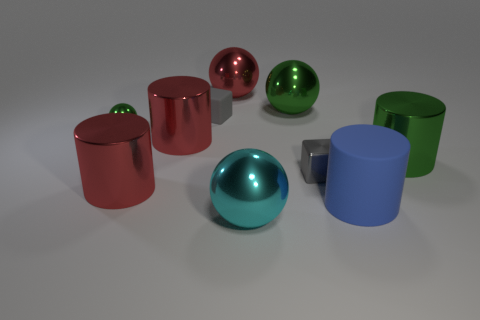What is the block to the right of the big shiny sphere in front of the large metallic object to the right of the big rubber cylinder made of?
Provide a succinct answer. Metal. Are there more small green balls behind the matte block than small green metallic objects that are left of the gray metallic thing?
Offer a very short reply. No. How many metallic things are either big gray spheres or small green things?
Offer a terse response. 1. What is the shape of the object that is the same color as the metal block?
Your response must be concise. Cube. What is the green object that is right of the blue object made of?
Offer a very short reply. Metal. How many things are either big blue things or big balls that are in front of the large green ball?
Make the answer very short. 2. The gray metallic thing that is the same size as the gray matte thing is what shape?
Offer a very short reply. Cube. How many other big rubber cylinders have the same color as the big rubber cylinder?
Provide a short and direct response. 0. Is the material of the large cylinder right of the large blue thing the same as the cyan sphere?
Ensure brevity in your answer.  Yes. The gray metallic thing is what shape?
Provide a short and direct response. Cube. 